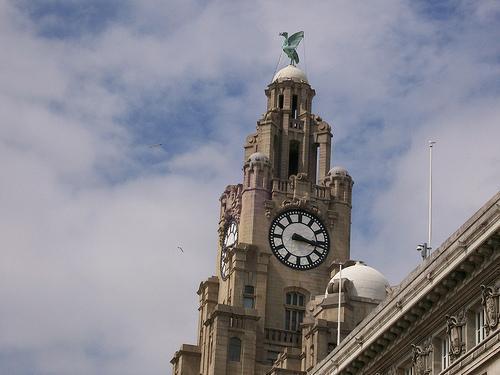How many birds are on top of the building?
Give a very brief answer. 1. 